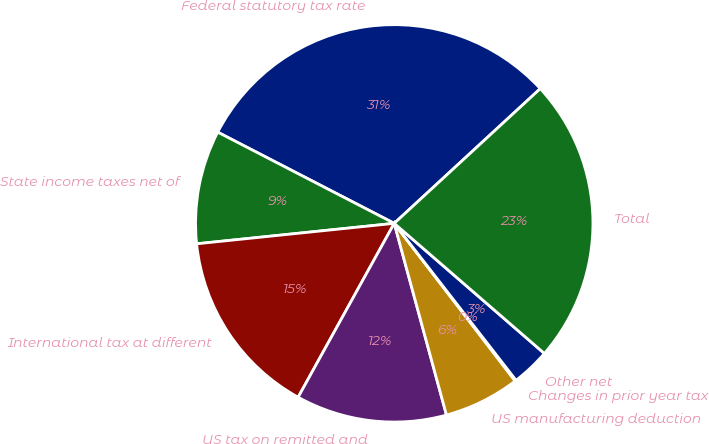Convert chart. <chart><loc_0><loc_0><loc_500><loc_500><pie_chart><fcel>Federal statutory tax rate<fcel>State income taxes net of<fcel>International tax at different<fcel>US tax on remitted and<fcel>US manufacturing deduction<fcel>Changes in prior year tax<fcel>Other net<fcel>Total<nl><fcel>30.55%<fcel>9.23%<fcel>15.32%<fcel>12.27%<fcel>6.18%<fcel>0.09%<fcel>3.13%<fcel>23.22%<nl></chart> 